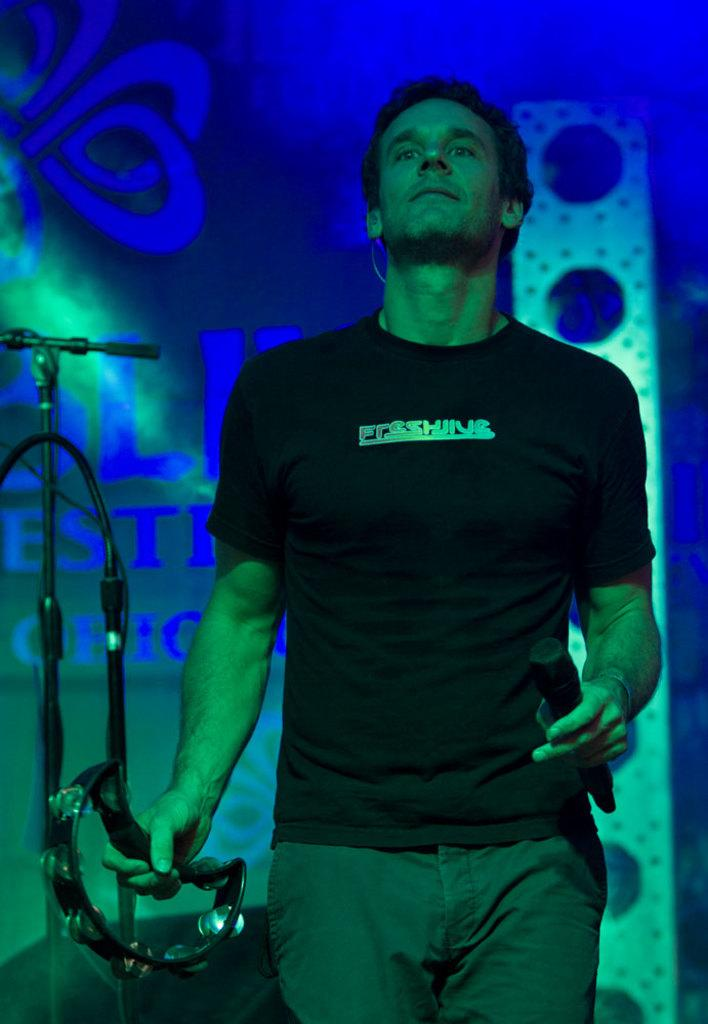What is the man in the image doing? The man is standing in the middle of the image and holding a microphone and a musical instrument. What is the man holding in his other hand? The man is holding a musical instrument. Can you describe the objects behind the man? There is a microphone and a banner behind the man. How does the pig feel about the moon in the image? There is no pig or mention of the moon in the image, so it is not possible to answer that question. 